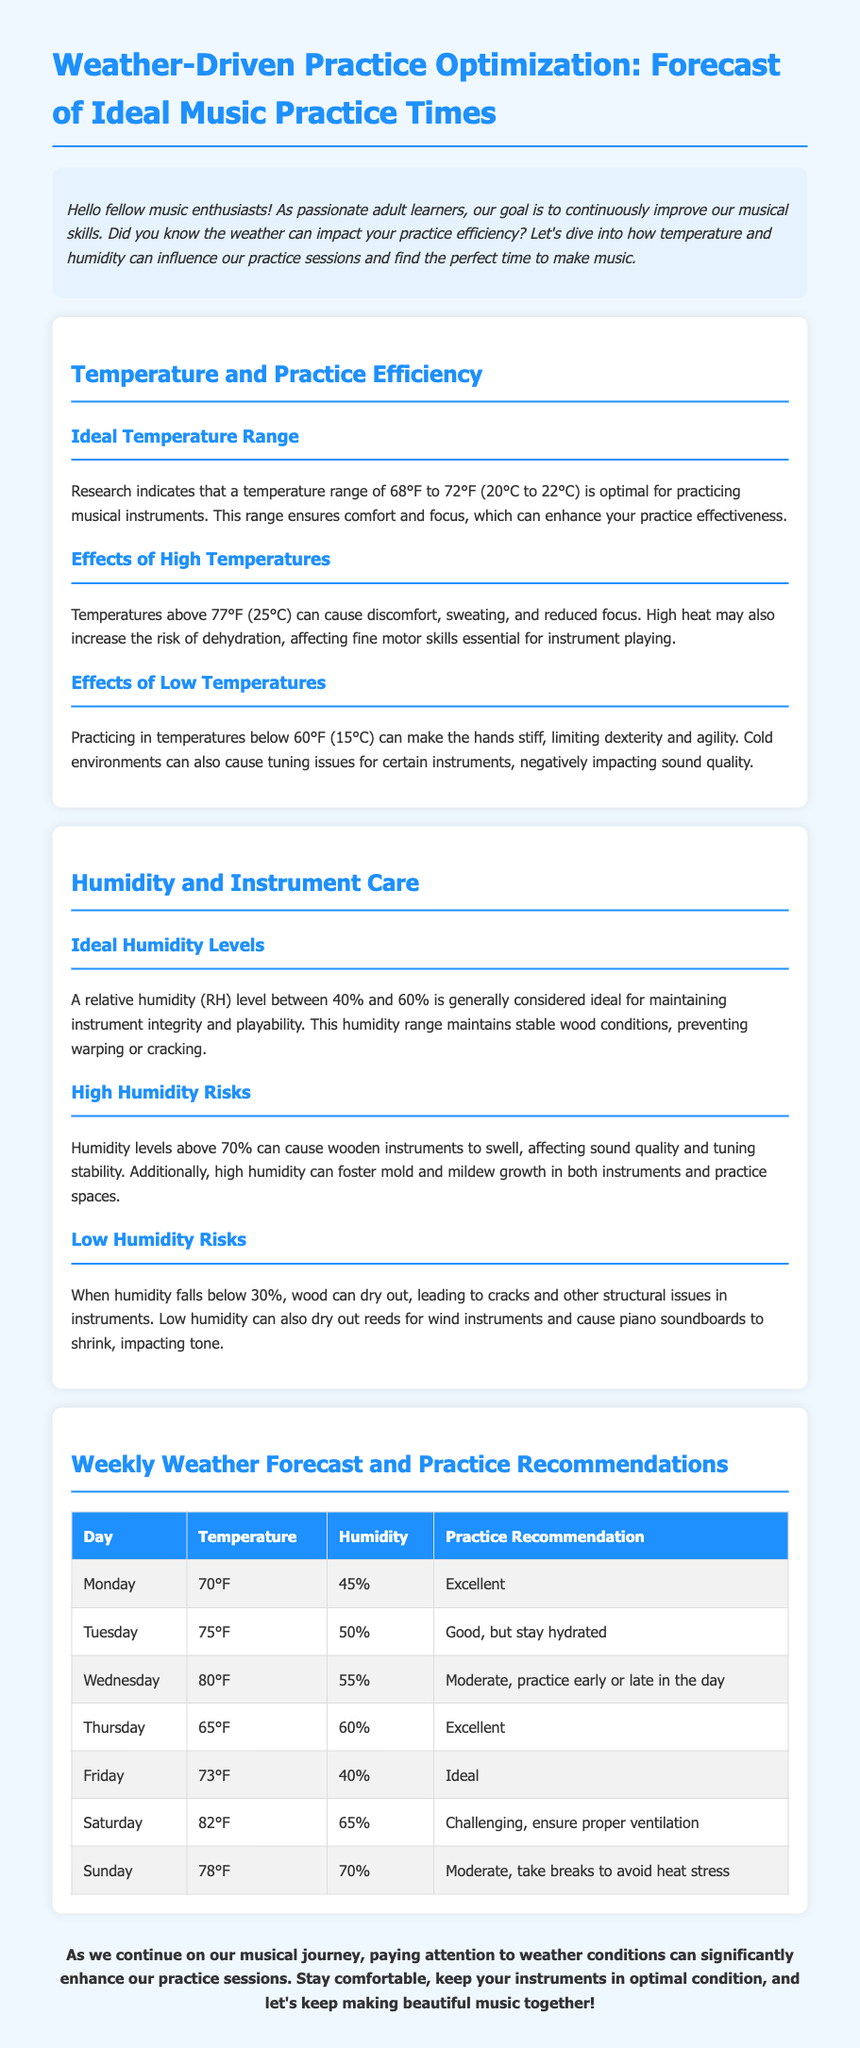What is the ideal temperature range for practicing? The ideal temperature range for practicing musical instruments is indicated as 68°F to 72°F (20°C to 22°C).
Answer: 68°F to 72°F What humidity level is considered ideal for maintaining instrument integrity? The document mentions that a relative humidity (RH) level between 40% and 60% is ideal for maintaining instrument integrity.
Answer: 40% to 60% On which day is the practice recommendation "Excellent"? The table lists "Excellent" practice recommendation for Monday and Thursday.
Answer: Monday and Thursday What temperature does the practice recommendation change to "Moderate"? The temperature rises to 80°F, leading to a "Moderate" practice recommendation on Wednesday.
Answer: 80°F What practice recommendation is given for Saturday? The document states that Saturday has a practice recommendation of "Challenging, ensure proper ventilation."
Answer: Challenging Which day has the lowest humidity level? The table highlights that Friday has the lowest humidity level at 40%.
Answer: 40% What is suggested for practicing on days with high temperatures, like Wednesday? The document suggests practicing early or late in the day on Wednesday due to high temperatures.
Answer: Early or late What is the practice recommendation for temperatures above 77°F? The recommendation states that temperatures above 77°F can lead to discomfort and reduced focus, thus impacting practice efficiency.
Answer: Discomfort and reduced focus What practice recommendation is provided for Sunday? The practice recommendation for Sunday is "Moderate, take breaks to avoid heat stress."
Answer: Moderate, take breaks 